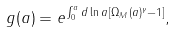<formula> <loc_0><loc_0><loc_500><loc_500>g ( a ) = e ^ { \int _ { 0 } ^ { a } d \ln a \, [ \Omega _ { M } ( a ) ^ { \gamma } - 1 ] } ,</formula> 